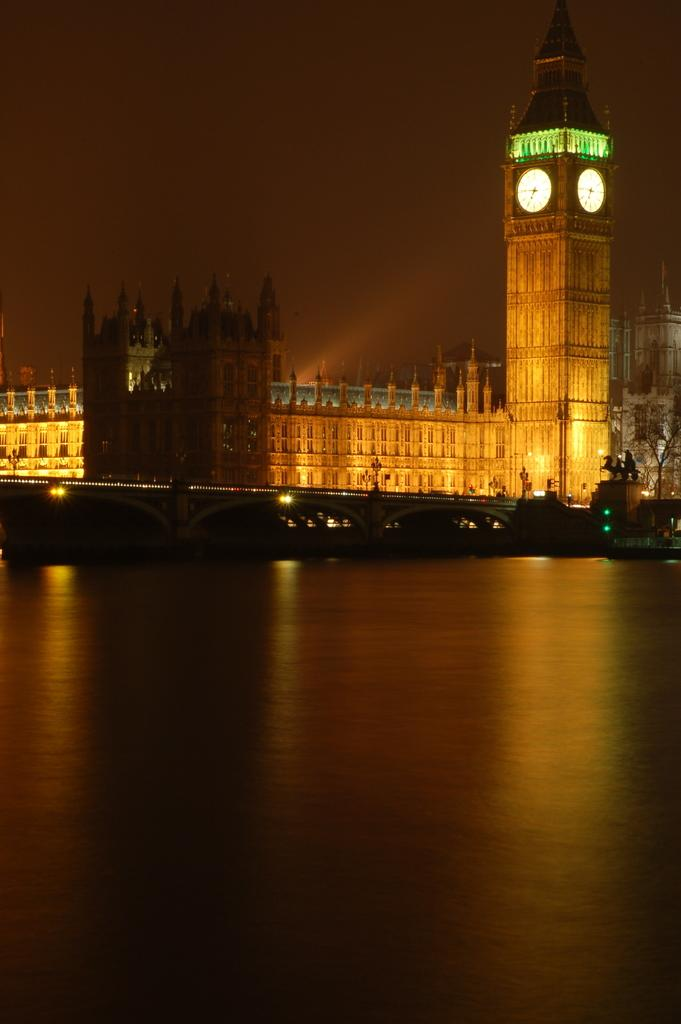What is the main feature of the image? There is water in the image. What structure is present in the middle of the image? There is a bridge at the center of the image. What can be seen in the background of the image? There are buildings, trees, lights, and the sky visible in the background of the image. What is the opinion of the thumb in the image? There is no thumb present in the image, so it is not possible to determine its opinion. 